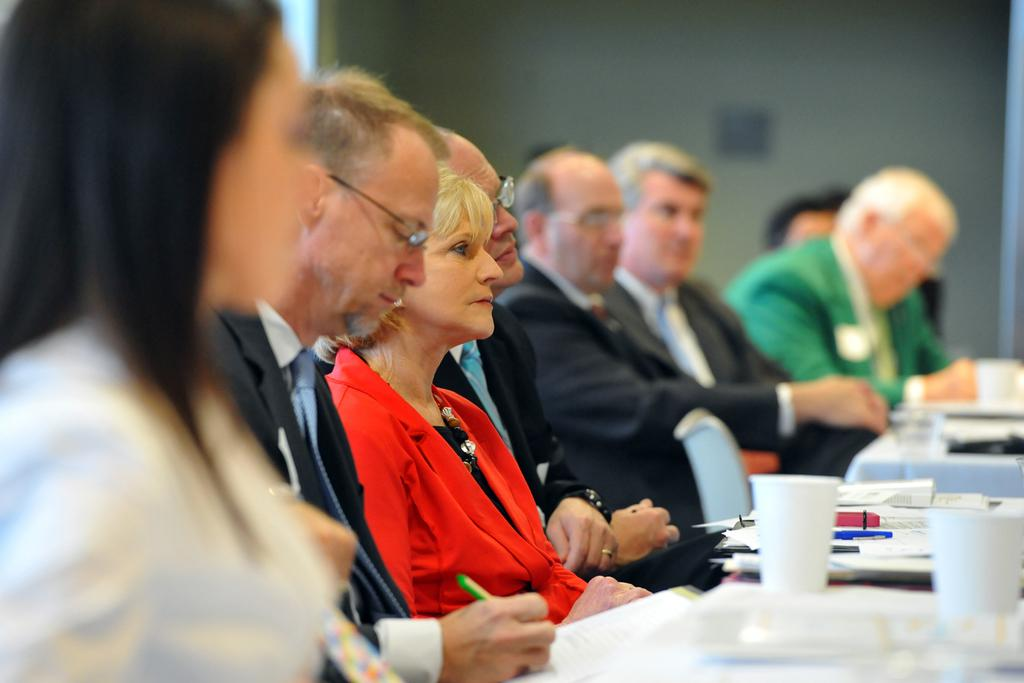How many people are in the image? There is a group of people in the image, but the exact number cannot be determined from the provided facts. What are the people doing in the image? The people are sitting in front of tables. What can be found on the tables in the image? There are cups, papers, pens, and other objects on the tables. Can you see a deer in the image? No, there is no deer present in the image. What word is written on the papers on the tables? The provided facts do not mention any specific words written on the papers, so we cannot determine that information. 